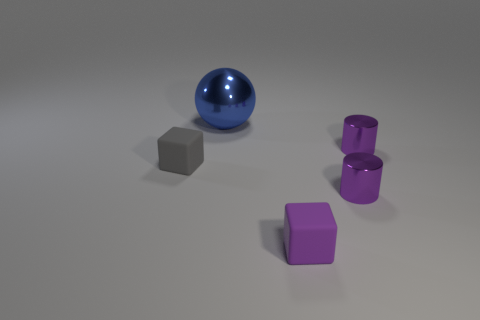What could be the context or purpose of this arrangement of objects? This arrangement of objects may serve an illustrative purpose, often used in educational materials to teach about geometry, color contrasts, and spatial perception. It might also be an artistic setup designed to convey simplicity and balance, or a scene designed for a 3D modeling practice, showcasing different shapes and shades under uniform lighting. 